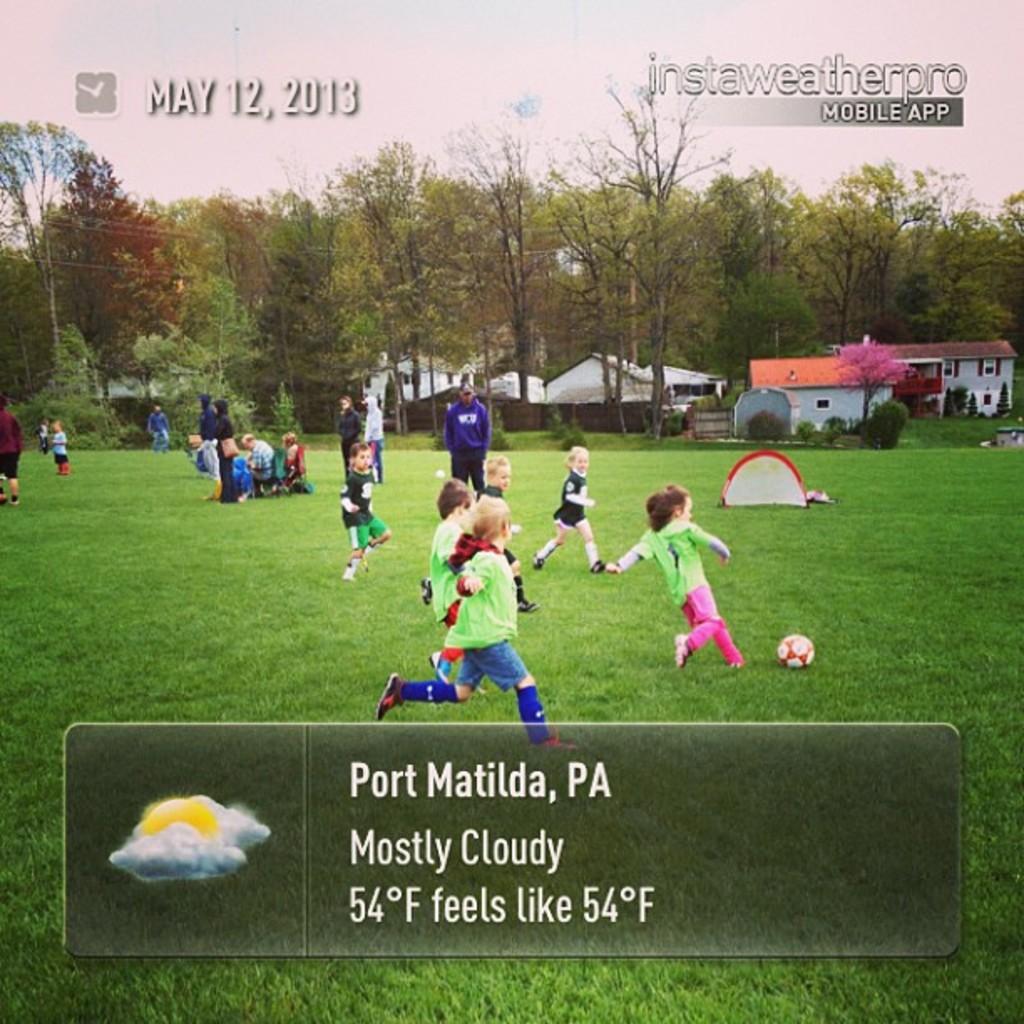In one or two sentences, can you explain what this image depicts? In this image there are kids playing a football. Behind them there a few other people. At the bottom of the image there is grass on the surface. In the background of the image there are buildings, plants, trees and sky. There is some text and logo on the image. 